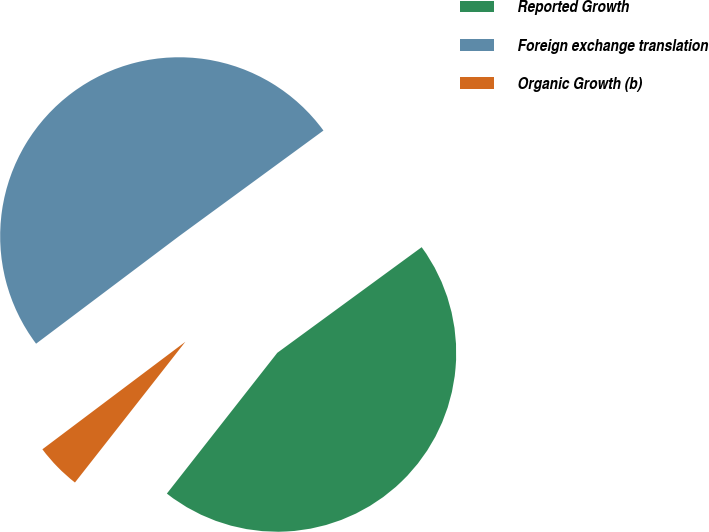Convert chart to OTSL. <chart><loc_0><loc_0><loc_500><loc_500><pie_chart><fcel>Reported Growth<fcel>Foreign exchange translation<fcel>Organic Growth (b)<nl><fcel>45.64%<fcel>50.21%<fcel>4.15%<nl></chart> 